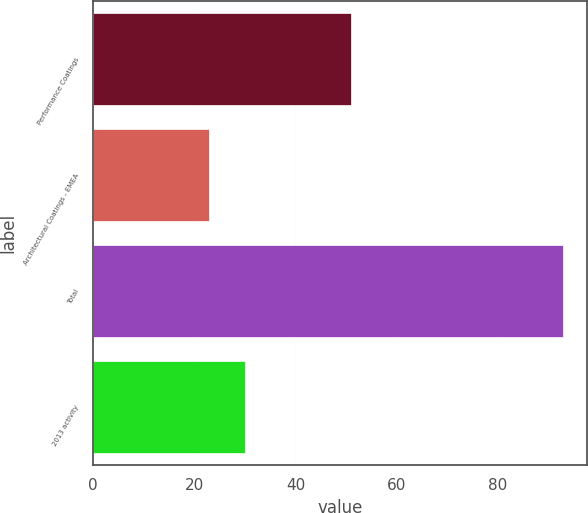Convert chart. <chart><loc_0><loc_0><loc_500><loc_500><bar_chart><fcel>Performance Coatings<fcel>Architectural Coatings - EMEA<fcel>Total<fcel>2013 activity<nl><fcel>51<fcel>23<fcel>93<fcel>30<nl></chart> 